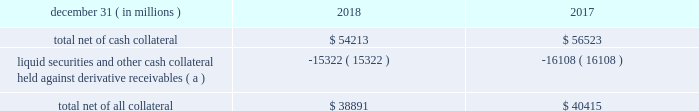Jpmorgan chase & co./2018 form 10-k 117 lending-related commitments the firm uses lending-related financial instruments , such as commitments ( including revolving credit facilities ) and guarantees , to address the financing needs of its clients .
The contractual amounts of these financial instruments represent the maximum possible credit risk should the clients draw down on these commitments or the firm fulfill its obligations under these guarantees , and the clients subsequently fail to perform according to the terms of these contracts .
Most of these commitments and guarantees are refinanced , extended , cancelled , or expire without being drawn upon or a default occurring .
In the firm 2019s view , the total contractual amount of these wholesale lending-related commitments is not representative of the firm 2019s expected future credit exposure or funding requirements .
For further information on wholesale lending-related commitments , refer to note 27 .
Clearing services the firm provides clearing services for clients entering into certain securities and derivative contracts .
Through the provision of these services the firm is exposed to the risk of non-performance by its clients and may be required to share in losses incurred by ccps .
Where possible , the firm seeks to mitigate its credit risk to its clients through the collection of adequate margin at inception and throughout the life of the transactions and can also cease provision of clearing services if clients do not adhere to their obligations under the clearing agreement .
For further discussion of clearing services , refer to note 27 .
Derivative contracts derivatives enable clients and counterparties to manage risks including credit risk and risks arising from fluctuations in interest rates , foreign exchange , equities , and commodities .
The firm makes markets in derivatives in order to meet these needs and uses derivatives to manage certain risks associated with net open risk positions from its market-making activities , including the counterparty credit risk arising from derivative receivables .
The firm also uses derivative instruments to manage its own credit and other market risk exposure .
The nature of the counterparty and the settlement mechanism of the derivative affect the credit risk to which the firm is exposed .
For otc derivatives the firm is exposed to the credit risk of the derivative counterparty .
For exchange-traded derivatives ( 201cetd 201d ) , such as futures and options , and 201ccleared 201d over-the-counter ( 201cotc-cleared 201d ) derivatives , the firm is generally exposed to the credit risk of the relevant ccp .
Where possible , the firm seeks to mitigate its credit risk exposures arising from derivative contracts through the use of legally enforceable master netting arrangements and collateral agreements .
For a further discussion of derivative contracts , counterparties and settlement types , refer to note 5 .
The table summarizes the net derivative receivables for the periods presented .
Derivative receivables .
( a ) includes collateral related to derivative instruments where appropriate legal opinions have not been either sought or obtained with respect to master netting agreements .
The fair value of derivative receivables reported on the consolidated balance sheets were $ 54.2 billion and $ 56.5 billion at december 31 , 2018 and 2017 , respectively .
Derivative receivables represent the fair value of the derivative contracts after giving effect to legally enforceable master netting agreements and cash collateral held by the firm .
However , in management 2019s view , the appropriate measure of current credit risk should also take into consideration additional liquid securities ( primarily u.s .
Government and agency securities and other group of seven nations ( 201cg7 201d ) government securities ) and other cash collateral held by the firm aggregating $ 15.3 billion and $ 16.1 billion at december 31 , 2018 and 2017 , respectively , that may be used as security when the fair value of the client 2019s exposure is in the firm 2019s favor .
In addition to the collateral described in the preceding paragraph , the firm also holds additional collateral ( primarily cash , g7 government securities , other liquid government-agency and guaranteed securities , and corporate debt and equity securities ) delivered by clients at the initiation of transactions , as well as collateral related to contracts that have a non-daily call frequency and collateral that the firm has agreed to return but has not yet settled as of the reporting date .
Although this collateral does not reduce the balances and is not included in the table above , it is available as security against potential exposure that could arise should the fair value of the client 2019s derivative contracts move in the firm 2019s favor .
The derivative receivables fair value , net of all collateral , also does not include other credit enhancements , such as letters of credit .
For additional information on the firm 2019s use of collateral agreements , refer to note 5 .
While useful as a current view of credit exposure , the net fair value of the derivative receivables does not capture the potential future variability of that credit exposure .
To capture the potential future variability of credit exposure , the firm calculates , on a client-by-client basis , three measures of potential derivatives-related credit loss : peak , derivative risk equivalent ( 201cdre 201d ) , and average exposure ( 201cavg 201d ) .
These measures all incorporate netting and collateral benefits , where applicable .
Peak represents a conservative measure of potential exposure to a counterparty calculated in a manner that is broadly equivalent to a 97.5% ( 97.5 % ) confidence level over the life of the transaction .
Peak is the primary measure used by the firm for setting of credit limits for derivative contracts , senior management reporting and derivatives exposure management .
Dre exposure is a measure that expresses the risk of derivative exposure on a basis intended to be .
In 2018 review of the net derivative receivable what was the ratio of the total net of cash collateral to the liquid securities and other cash collateral held against derivative receivables? 
Computations: (54213 / 15322)
Answer: 3.53825. 